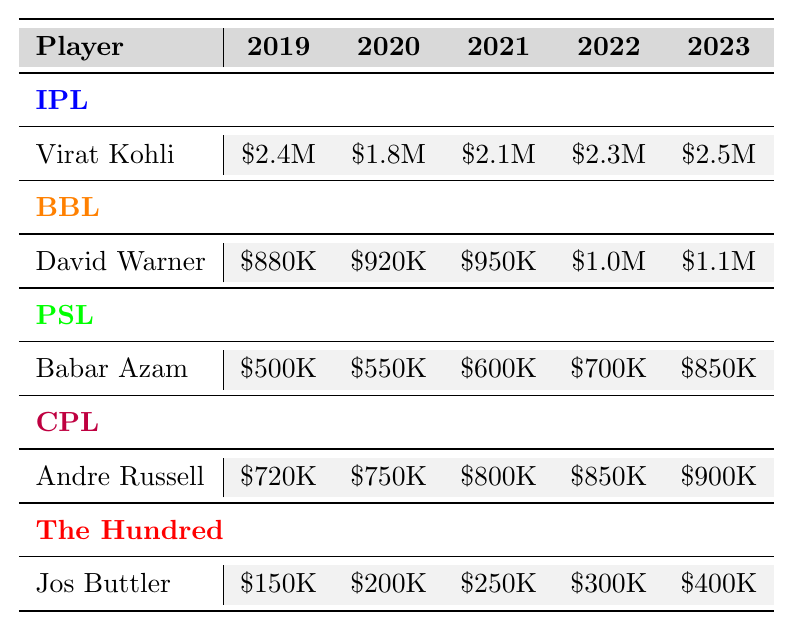What is the highest transfer fee for Virat Kohli? The highest transfer fee for Virat Kohli in the table is listed for the year 2023, which is \$2.5 million.
Answer: \$2.5 million What was Babar Azam's transfer fee in 2021? The transfer fee for Babar Azam in 2021 is \$600,000, as shown in the table under the PSL section.
Answer: \$600,000 Which player received the lowest transfer fee in 2019? The lowest transfer fee in 2019 is for Jos Buttler, who received \$150,000.
Answer: \$150,000 What is the average transfer fee of Andre Russell over the years? Sum the transfer fees for Andre Russell for the years 2019 to 2023: (720,000 + 750,000 + 800,000 + 850,000 + 900,000) = 4,020,000. The average is 4,020,000 / 5 = 804,000.
Answer: \$804,000 Did David Warner's transfer fee ever drop from one year to the next? Yes, David Warner's transfer fee dropped from \$2,400,000 in 2019 to \$1,800,000 in 2020.
Answer: Yes What was the increase in transfer fee for Jos Buttler from 2022 to 2023? Jos Buttler's transfer fee in 2022 was \$300,000, and in 2023, it increased to \$400,000. The increase is \$400,000 - \$300,000 = \$100,000.
Answer: \$100,000 Which player had the highest overall transfer fee between 2019 and 2023? Summing the fees for each player, Virat Kohli has the highest total: (2,400,000 + 1,800,000 + 2,100,000 + 2,300,000 + 2,500,000) = 12,100,000. This is higher than any other player’s total.
Answer: Virat Kohli What is the total transfer fee for all players in the year 2022? Adding the transfer fees for all players in 2022: (2,300,000 + 1,000,000 + 700,000 + 850,000 + 300,000) = 5,150,000.
Answer: \$5,150,000 Is the average transfer fee in 2020 higher than in 2021? Calculate the average for both years: 2020 average is (1,800,000 + 920,000 + 550,000 + 750,000 + 200,000) = 3,220,000 / 5 = 644,000; 2021 average is (2,100,000 + 950,000 + 600,000 + 800,000 + 250,000) = 4,700,000 / 5 = 940,000. Since 644,000 < 940,000, the statement is false.
Answer: No What is the difference in total transfer fees for Andre Russell between 2019 and 2023? The total for Andre Russell in 2019 is \$720,000 and in 2023 is \$900,000. The difference is \$900,000 - \$720,000 = \$180,000.
Answer: \$180,000 